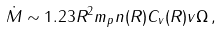<formula> <loc_0><loc_0><loc_500><loc_500>\dot { M } \sim 1 . 2 3 R ^ { 2 } m _ { p } n ( R ) { C _ { v } } { ( R ) } v \Omega \, ,</formula> 